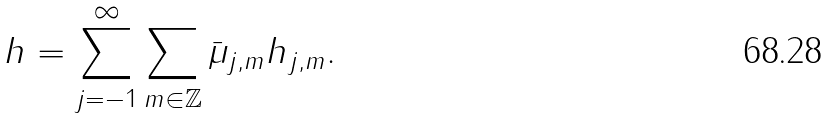Convert formula to latex. <formula><loc_0><loc_0><loc_500><loc_500>h = \sum _ { j = - 1 } ^ { \infty } \sum _ { m \in \mathbb { Z } } \bar { \mu } _ { j , m } h _ { j , m } .</formula> 